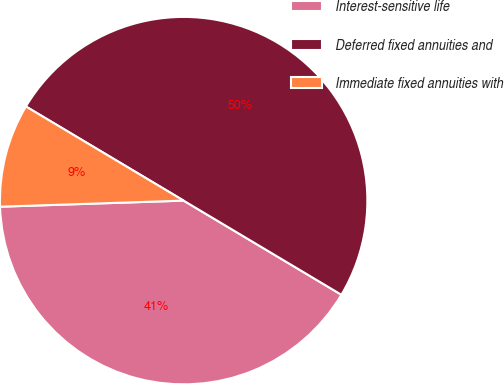Convert chart to OTSL. <chart><loc_0><loc_0><loc_500><loc_500><pie_chart><fcel>Interest-sensitive life<fcel>Deferred fixed annuities and<fcel>Immediate fixed annuities with<nl><fcel>40.91%<fcel>50.0%<fcel>9.09%<nl></chart> 